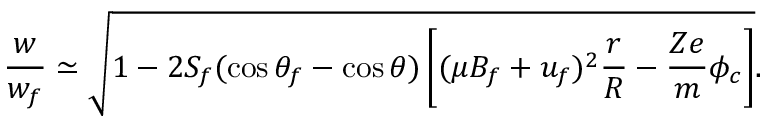Convert formula to latex. <formula><loc_0><loc_0><loc_500><loc_500>\frac { w } { w _ { f } } \simeq \sqrt { 1 - 2 S _ { f } ( \cos \theta _ { f } - \cos \theta ) \left [ ( \mu B _ { f } + u _ { f } ) ^ { 2 } \frac { r } { R } - \frac { Z e } { m } \phi _ { c } \right ] } .</formula> 